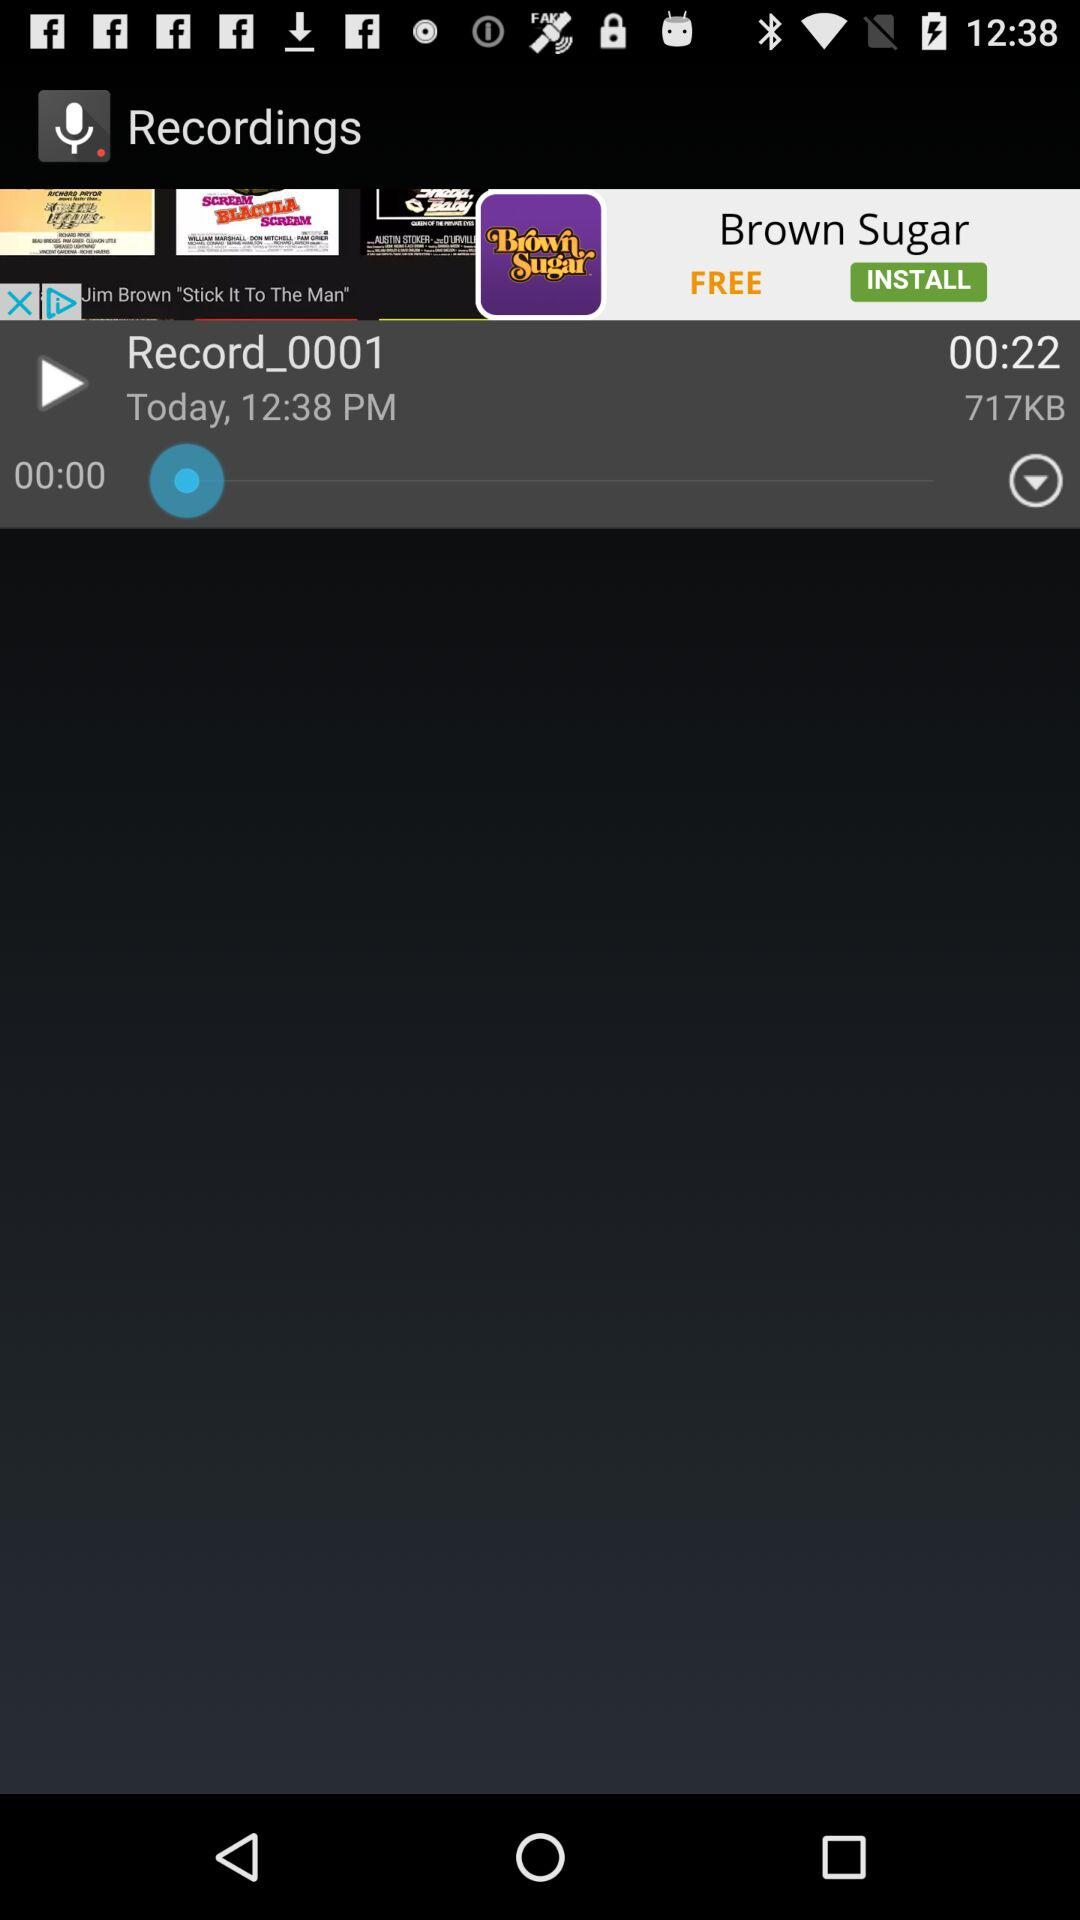How many recordings are downloaded?
When the provided information is insufficient, respond with <no answer>. <no answer> 